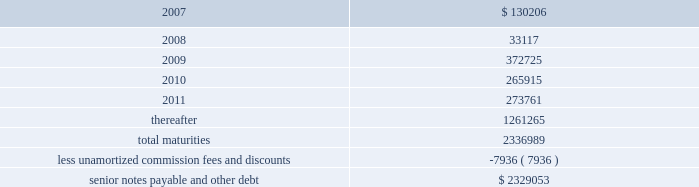Ventas , inc .
Notes to consolidated financial statements 2014 ( continued ) if we experience certain kinds of changes of control , the issuers must make an offer to repurchase the senior notes , in whole or in part , at a purchase price in cash equal to 101% ( 101 % ) of the principal amount of the senior notes , plus any accrued and unpaid interest to the date of purchase ; provided , however , that in the event moody 2019s and s&p have confirmed their ratings at ba3 or higher and bb- or higher on the senior notes and certain other conditions are met , this repurchase obligation will not apply .
Mortgages at december 31 , 2006 , we had outstanding 53 mortgage loans that we assumed in connection with various acquisitions .
Outstanding principal balances on these loans ranged from $ 0.4 million to $ 114.4 million as of december 31 , 2006 .
The loans bear interest at fixed rates ranging from 5.6% ( 5.6 % ) to 8.5% ( 8.5 % ) per annum , except with respect to eight loans with outstanding principal balances ranging from $ 0.4 million to $ 114.4 million , which bear interest at the lender 2019s variable rates , ranging from 3.6% ( 3.6 % ) to 8.5% ( 8.5 % ) per annum at of december 31 , 2006 .
The fixed rate debt bears interest at a weighted average annual rate of 7.06% ( 7.06 % ) and the variable rate debt bears interest at a weighted average annual rate of 5.61% ( 5.61 % ) as of december 31 , 2006 .
The loans had a weighted average maturity of eight years as of december 31 , 2006 .
The $ 114.4 variable mortgage debt was repaid in january 2007 .
Scheduled maturities of borrowing arrangements and other provisions as of december 31 , 2006 , our indebtedness has the following maturities ( in thousands ) : .
Certain provisions of our long-term debt contain covenants that limit our ability and the ability of certain of our subsidiaries to , among other things : ( i ) incur debt ; ( ii ) make certain dividends , distributions and investments ; ( iii ) enter into certain transactions ; ( iv ) merge , consolidate or transfer certain assets ; and ( v ) sell assets .
We and certain of our subsidiaries are also required to maintain total unencumbered assets of at least 150% ( 150 % ) of this group 2019s unsecured debt .
Derivatives and hedging in the normal course of business , we are exposed to the effect of interest rate changes .
We limit these risks by following established risk management policies and procedures including the use of derivatives .
For interest rate exposures , derivatives are used primarily to fix the rate on debt based on floating-rate indices and to manage the cost of borrowing obligations .
We currently have an interest rate swap to manage interest rate risk ( the 201cswap 201d ) .
We prohibit the use of derivative instruments for trading or speculative purposes .
Further , we have a policy of only entering into contracts with major financial institutions based upon their credit ratings and other factors .
When viewed in conjunction with the underlying and offsetting exposure that the derivative is designed to hedge , we do not anticipate any material adverse effect on our net income or financial position in the future from the use of derivatives. .
What percentage of total maturities amortize after 2011? 
Computations: (1261265 / 2336989)
Answer: 0.5397. 